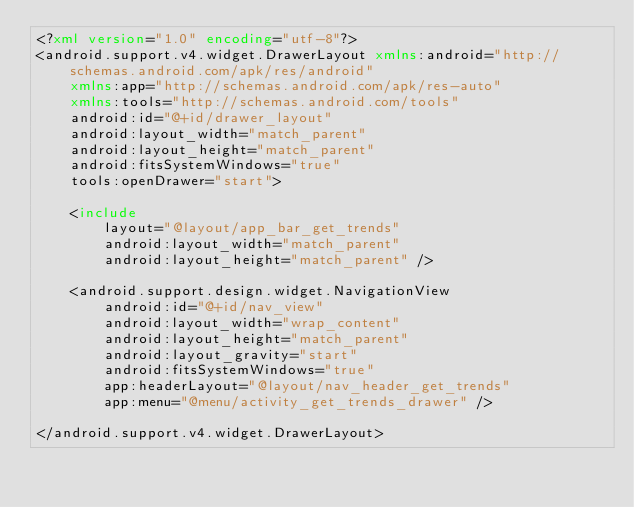<code> <loc_0><loc_0><loc_500><loc_500><_XML_><?xml version="1.0" encoding="utf-8"?>
<android.support.v4.widget.DrawerLayout xmlns:android="http://schemas.android.com/apk/res/android"
    xmlns:app="http://schemas.android.com/apk/res-auto"
    xmlns:tools="http://schemas.android.com/tools"
    android:id="@+id/drawer_layout"
    android:layout_width="match_parent"
    android:layout_height="match_parent"
    android:fitsSystemWindows="true"
    tools:openDrawer="start">

    <include
        layout="@layout/app_bar_get_trends"
        android:layout_width="match_parent"
        android:layout_height="match_parent" />

    <android.support.design.widget.NavigationView
        android:id="@+id/nav_view"
        android:layout_width="wrap_content"
        android:layout_height="match_parent"
        android:layout_gravity="start"
        android:fitsSystemWindows="true"
        app:headerLayout="@layout/nav_header_get_trends"
        app:menu="@menu/activity_get_trends_drawer" />

</android.support.v4.widget.DrawerLayout>
</code> 